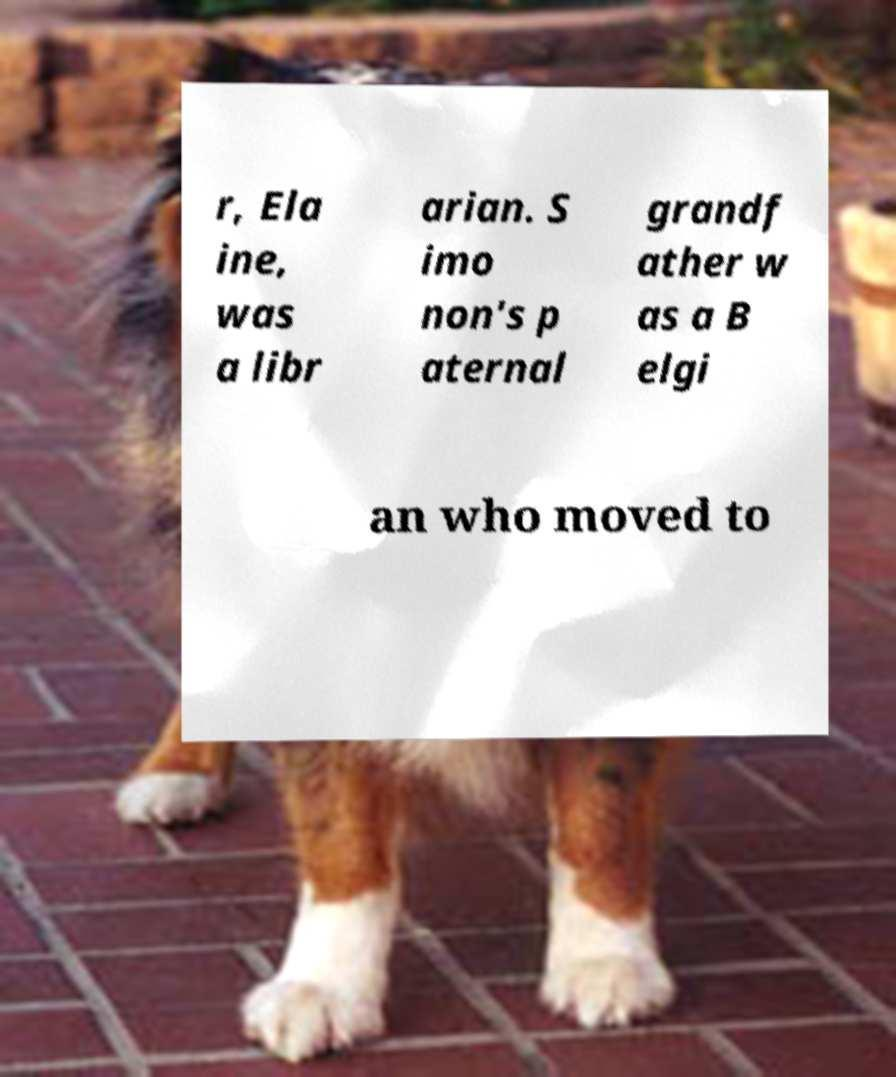Could you extract and type out the text from this image? r, Ela ine, was a libr arian. S imo non's p aternal grandf ather w as a B elgi an who moved to 